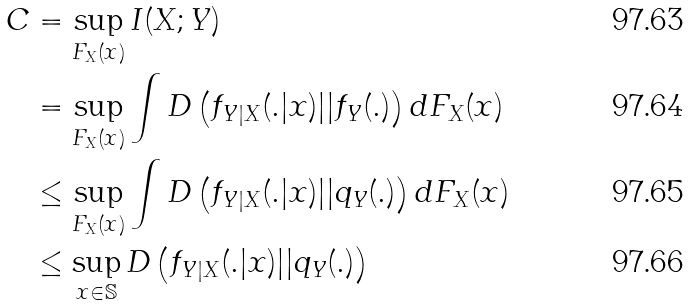<formula> <loc_0><loc_0><loc_500><loc_500>C & = \sup _ { F _ { X } ( x ) } I ( X ; Y ) \\ & = \sup _ { F _ { X } ( x ) } \int { D \left ( f _ { Y | X } ( . | x ) | | f _ { Y } ( . ) \right ) d F _ { X } ( x ) } \\ & \leq \sup _ { F _ { X } ( x ) } \int { D \left ( f _ { Y | X } ( . | x ) | | q _ { Y } ( . ) \right ) d F _ { X } ( x ) } \\ & \leq \sup _ { x \in \mathbb { S } } D \left ( f _ { Y | X } ( . | x ) | | q _ { Y } ( . ) \right )</formula> 